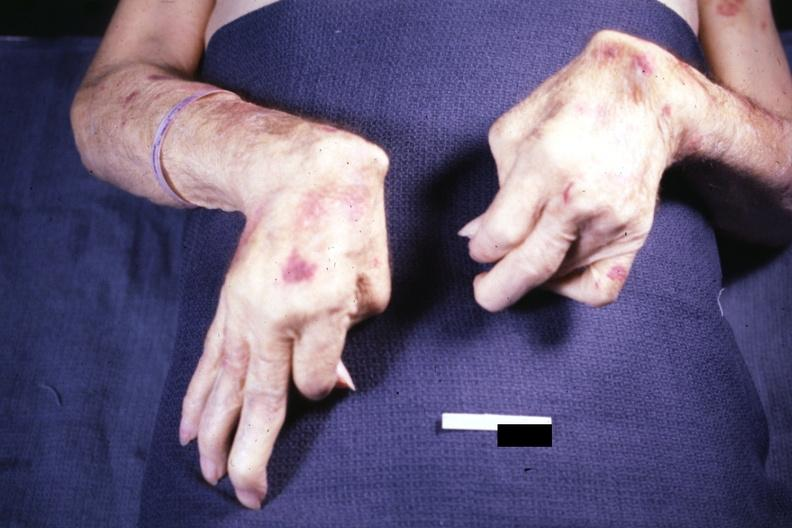re extremities present?
Answer the question using a single word or phrase. Yes 